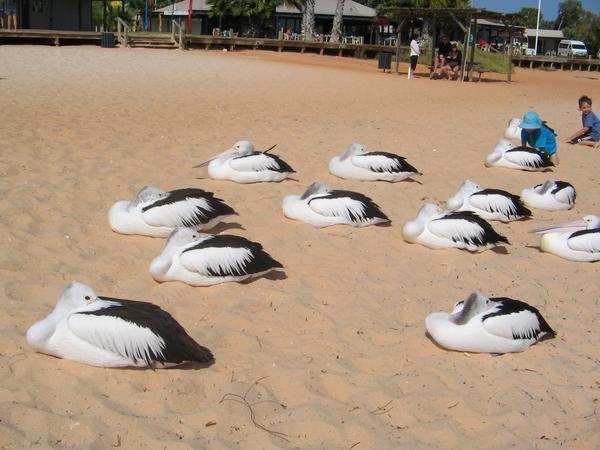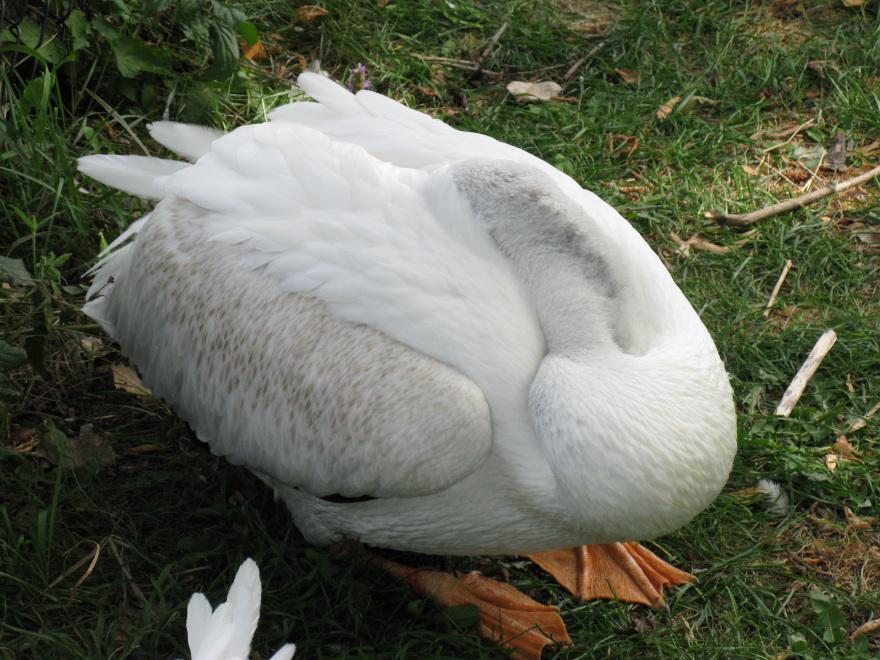The first image is the image on the left, the second image is the image on the right. For the images shown, is this caption "There's no more than two birds." true? Answer yes or no. No. The first image is the image on the left, the second image is the image on the right. Assess this claim about the two images: "One image shows a single white bird tucked into an egg shape, and the other shows a group of black-and-white birds with necks tucked backward.". Correct or not? Answer yes or no. Yes. 